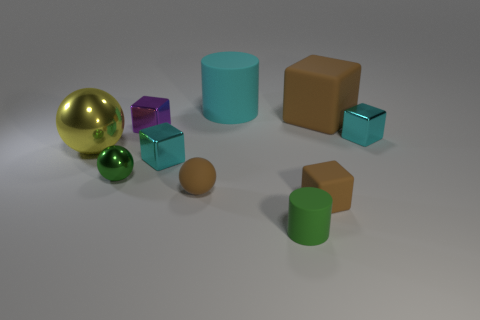Subtract all purple cubes. How many cubes are left? 4 Subtract all purple shiny cubes. How many cubes are left? 4 Subtract 1 blocks. How many blocks are left? 4 Subtract all green cubes. Subtract all red spheres. How many cubes are left? 5 Subtract all cylinders. How many objects are left? 8 Subtract all tiny green cylinders. Subtract all tiny rubber balls. How many objects are left? 8 Add 2 small purple blocks. How many small purple blocks are left? 3 Add 4 large yellow things. How many large yellow things exist? 5 Subtract 0 blue cylinders. How many objects are left? 10 